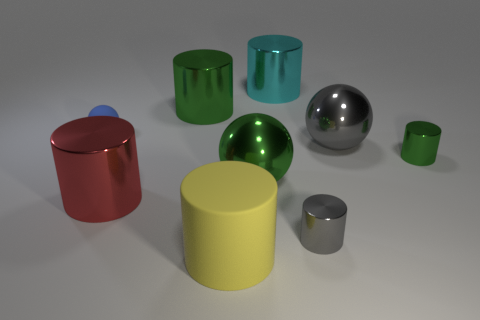Subtract 2 cylinders. How many cylinders are left? 4 Subtract all green shiny cylinders. How many cylinders are left? 4 Subtract all gray cylinders. How many cylinders are left? 5 Subtract all purple cylinders. Subtract all gray cubes. How many cylinders are left? 6 Add 1 green objects. How many objects exist? 10 Subtract all cylinders. How many objects are left? 3 Subtract all big red cubes. Subtract all gray shiny cylinders. How many objects are left? 8 Add 9 green spheres. How many green spheres are left? 10 Add 1 cylinders. How many cylinders exist? 7 Subtract 1 cyan cylinders. How many objects are left? 8 